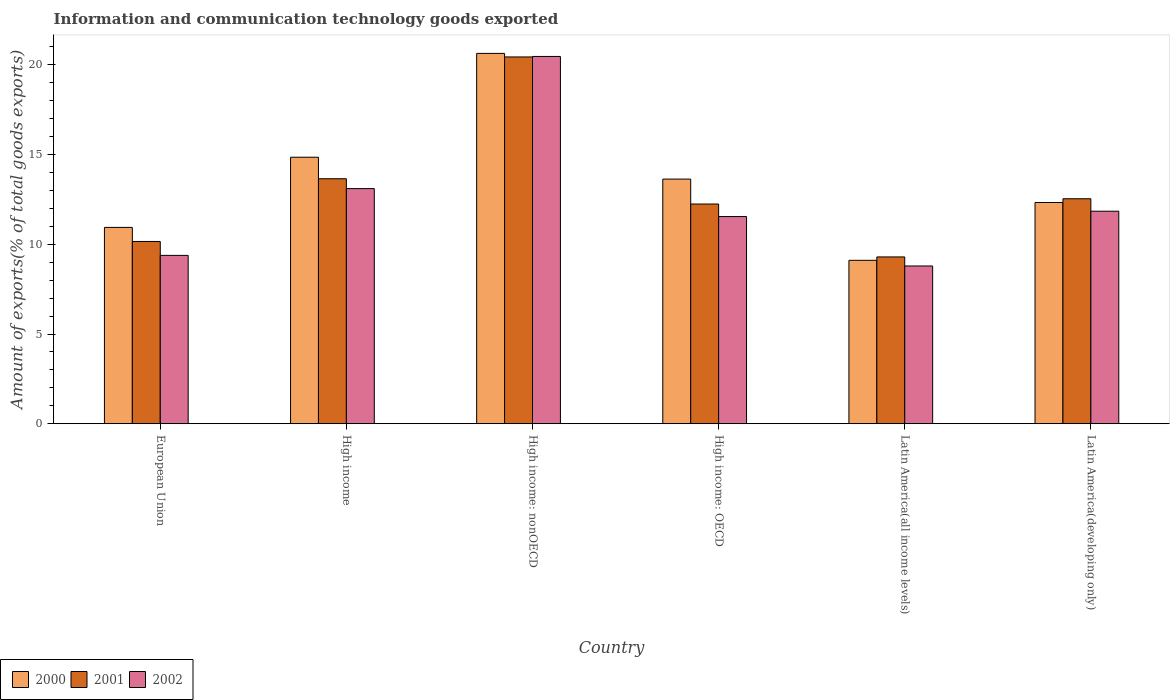How many different coloured bars are there?
Keep it short and to the point. 3. How many groups of bars are there?
Your answer should be very brief. 6. Are the number of bars per tick equal to the number of legend labels?
Your response must be concise. Yes. Are the number of bars on each tick of the X-axis equal?
Offer a terse response. Yes. How many bars are there on the 4th tick from the left?
Keep it short and to the point. 3. How many bars are there on the 5th tick from the right?
Offer a terse response. 3. What is the amount of goods exported in 2001 in High income: OECD?
Keep it short and to the point. 12.24. Across all countries, what is the maximum amount of goods exported in 2001?
Offer a terse response. 20.44. Across all countries, what is the minimum amount of goods exported in 2002?
Your answer should be very brief. 8.79. In which country was the amount of goods exported in 2002 maximum?
Provide a succinct answer. High income: nonOECD. In which country was the amount of goods exported in 2001 minimum?
Your answer should be very brief. Latin America(all income levels). What is the total amount of goods exported in 2001 in the graph?
Keep it short and to the point. 78.33. What is the difference between the amount of goods exported in 2001 in High income and that in Latin America(developing only)?
Your answer should be compact. 1.12. What is the difference between the amount of goods exported in 2002 in High income and the amount of goods exported in 2000 in High income: OECD?
Your answer should be compact. -0.53. What is the average amount of goods exported in 2001 per country?
Your answer should be very brief. 13.05. What is the difference between the amount of goods exported of/in 2001 and amount of goods exported of/in 2002 in Latin America(developing only)?
Provide a succinct answer. 0.69. What is the ratio of the amount of goods exported in 2002 in High income to that in Latin America(all income levels)?
Provide a succinct answer. 1.49. Is the amount of goods exported in 2001 in European Union less than that in High income?
Your response must be concise. Yes. Is the difference between the amount of goods exported in 2001 in High income and High income: OECD greater than the difference between the amount of goods exported in 2002 in High income and High income: OECD?
Offer a terse response. No. What is the difference between the highest and the second highest amount of goods exported in 2002?
Provide a short and direct response. -8.62. What is the difference between the highest and the lowest amount of goods exported in 2002?
Keep it short and to the point. 11.68. What does the 3rd bar from the left in High income: nonOECD represents?
Keep it short and to the point. 2002. What does the 2nd bar from the right in Latin America(all income levels) represents?
Keep it short and to the point. 2001. Are all the bars in the graph horizontal?
Keep it short and to the point. No. How many countries are there in the graph?
Make the answer very short. 6. Where does the legend appear in the graph?
Provide a short and direct response. Bottom left. How many legend labels are there?
Keep it short and to the point. 3. How are the legend labels stacked?
Offer a very short reply. Horizontal. What is the title of the graph?
Make the answer very short. Information and communication technology goods exported. Does "1992" appear as one of the legend labels in the graph?
Provide a succinct answer. No. What is the label or title of the X-axis?
Provide a short and direct response. Country. What is the label or title of the Y-axis?
Offer a very short reply. Amount of exports(% of total goods exports). What is the Amount of exports(% of total goods exports) in 2000 in European Union?
Ensure brevity in your answer.  10.94. What is the Amount of exports(% of total goods exports) of 2001 in European Union?
Give a very brief answer. 10.16. What is the Amount of exports(% of total goods exports) of 2002 in European Union?
Offer a very short reply. 9.38. What is the Amount of exports(% of total goods exports) of 2000 in High income?
Provide a succinct answer. 14.85. What is the Amount of exports(% of total goods exports) of 2001 in High income?
Give a very brief answer. 13.65. What is the Amount of exports(% of total goods exports) of 2002 in High income?
Keep it short and to the point. 13.1. What is the Amount of exports(% of total goods exports) in 2000 in High income: nonOECD?
Provide a short and direct response. 20.64. What is the Amount of exports(% of total goods exports) in 2001 in High income: nonOECD?
Your answer should be compact. 20.44. What is the Amount of exports(% of total goods exports) in 2002 in High income: nonOECD?
Make the answer very short. 20.47. What is the Amount of exports(% of total goods exports) in 2000 in High income: OECD?
Your response must be concise. 13.63. What is the Amount of exports(% of total goods exports) of 2001 in High income: OECD?
Make the answer very short. 12.24. What is the Amount of exports(% of total goods exports) of 2002 in High income: OECD?
Your response must be concise. 11.55. What is the Amount of exports(% of total goods exports) in 2000 in Latin America(all income levels)?
Your answer should be compact. 9.11. What is the Amount of exports(% of total goods exports) of 2001 in Latin America(all income levels)?
Provide a short and direct response. 9.3. What is the Amount of exports(% of total goods exports) in 2002 in Latin America(all income levels)?
Give a very brief answer. 8.79. What is the Amount of exports(% of total goods exports) in 2000 in Latin America(developing only)?
Your response must be concise. 12.33. What is the Amount of exports(% of total goods exports) in 2001 in Latin America(developing only)?
Your answer should be compact. 12.54. What is the Amount of exports(% of total goods exports) in 2002 in Latin America(developing only)?
Your response must be concise. 11.84. Across all countries, what is the maximum Amount of exports(% of total goods exports) of 2000?
Make the answer very short. 20.64. Across all countries, what is the maximum Amount of exports(% of total goods exports) in 2001?
Offer a very short reply. 20.44. Across all countries, what is the maximum Amount of exports(% of total goods exports) of 2002?
Your answer should be compact. 20.47. Across all countries, what is the minimum Amount of exports(% of total goods exports) in 2000?
Your answer should be very brief. 9.11. Across all countries, what is the minimum Amount of exports(% of total goods exports) of 2001?
Give a very brief answer. 9.3. Across all countries, what is the minimum Amount of exports(% of total goods exports) in 2002?
Offer a terse response. 8.79. What is the total Amount of exports(% of total goods exports) in 2000 in the graph?
Offer a terse response. 81.5. What is the total Amount of exports(% of total goods exports) in 2001 in the graph?
Your response must be concise. 78.33. What is the total Amount of exports(% of total goods exports) in 2002 in the graph?
Your response must be concise. 75.13. What is the difference between the Amount of exports(% of total goods exports) of 2000 in European Union and that in High income?
Your answer should be very brief. -3.91. What is the difference between the Amount of exports(% of total goods exports) of 2001 in European Union and that in High income?
Make the answer very short. -3.49. What is the difference between the Amount of exports(% of total goods exports) in 2002 in European Union and that in High income?
Provide a succinct answer. -3.72. What is the difference between the Amount of exports(% of total goods exports) in 2000 in European Union and that in High income: nonOECD?
Offer a very short reply. -9.7. What is the difference between the Amount of exports(% of total goods exports) in 2001 in European Union and that in High income: nonOECD?
Ensure brevity in your answer.  -10.28. What is the difference between the Amount of exports(% of total goods exports) in 2002 in European Union and that in High income: nonOECD?
Provide a short and direct response. -11.09. What is the difference between the Amount of exports(% of total goods exports) of 2000 in European Union and that in High income: OECD?
Offer a very short reply. -2.69. What is the difference between the Amount of exports(% of total goods exports) in 2001 in European Union and that in High income: OECD?
Offer a very short reply. -2.09. What is the difference between the Amount of exports(% of total goods exports) of 2002 in European Union and that in High income: OECD?
Offer a terse response. -2.16. What is the difference between the Amount of exports(% of total goods exports) of 2000 in European Union and that in Latin America(all income levels)?
Ensure brevity in your answer.  1.83. What is the difference between the Amount of exports(% of total goods exports) in 2001 in European Union and that in Latin America(all income levels)?
Offer a terse response. 0.86. What is the difference between the Amount of exports(% of total goods exports) in 2002 in European Union and that in Latin America(all income levels)?
Offer a terse response. 0.59. What is the difference between the Amount of exports(% of total goods exports) of 2000 in European Union and that in Latin America(developing only)?
Provide a succinct answer. -1.39. What is the difference between the Amount of exports(% of total goods exports) in 2001 in European Union and that in Latin America(developing only)?
Give a very brief answer. -2.38. What is the difference between the Amount of exports(% of total goods exports) of 2002 in European Union and that in Latin America(developing only)?
Provide a short and direct response. -2.46. What is the difference between the Amount of exports(% of total goods exports) in 2000 in High income and that in High income: nonOECD?
Offer a very short reply. -5.79. What is the difference between the Amount of exports(% of total goods exports) of 2001 in High income and that in High income: nonOECD?
Offer a very short reply. -6.79. What is the difference between the Amount of exports(% of total goods exports) of 2002 in High income and that in High income: nonOECD?
Offer a terse response. -7.36. What is the difference between the Amount of exports(% of total goods exports) in 2000 in High income and that in High income: OECD?
Your answer should be very brief. 1.22. What is the difference between the Amount of exports(% of total goods exports) in 2001 in High income and that in High income: OECD?
Your answer should be compact. 1.41. What is the difference between the Amount of exports(% of total goods exports) of 2002 in High income and that in High income: OECD?
Make the answer very short. 1.56. What is the difference between the Amount of exports(% of total goods exports) in 2000 in High income and that in Latin America(all income levels)?
Provide a succinct answer. 5.75. What is the difference between the Amount of exports(% of total goods exports) of 2001 in High income and that in Latin America(all income levels)?
Keep it short and to the point. 4.36. What is the difference between the Amount of exports(% of total goods exports) in 2002 in High income and that in Latin America(all income levels)?
Your response must be concise. 4.31. What is the difference between the Amount of exports(% of total goods exports) in 2000 in High income and that in Latin America(developing only)?
Keep it short and to the point. 2.52. What is the difference between the Amount of exports(% of total goods exports) in 2001 in High income and that in Latin America(developing only)?
Keep it short and to the point. 1.12. What is the difference between the Amount of exports(% of total goods exports) in 2002 in High income and that in Latin America(developing only)?
Offer a very short reply. 1.26. What is the difference between the Amount of exports(% of total goods exports) in 2000 in High income: nonOECD and that in High income: OECD?
Your answer should be very brief. 7. What is the difference between the Amount of exports(% of total goods exports) in 2001 in High income: nonOECD and that in High income: OECD?
Make the answer very short. 8.2. What is the difference between the Amount of exports(% of total goods exports) in 2002 in High income: nonOECD and that in High income: OECD?
Provide a succinct answer. 8.92. What is the difference between the Amount of exports(% of total goods exports) in 2000 in High income: nonOECD and that in Latin America(all income levels)?
Provide a short and direct response. 11.53. What is the difference between the Amount of exports(% of total goods exports) of 2001 in High income: nonOECD and that in Latin America(all income levels)?
Your response must be concise. 11.14. What is the difference between the Amount of exports(% of total goods exports) in 2002 in High income: nonOECD and that in Latin America(all income levels)?
Offer a very short reply. 11.68. What is the difference between the Amount of exports(% of total goods exports) in 2000 in High income: nonOECD and that in Latin America(developing only)?
Your response must be concise. 8.31. What is the difference between the Amount of exports(% of total goods exports) of 2001 in High income: nonOECD and that in Latin America(developing only)?
Make the answer very short. 7.9. What is the difference between the Amount of exports(% of total goods exports) of 2002 in High income: nonOECD and that in Latin America(developing only)?
Your answer should be compact. 8.62. What is the difference between the Amount of exports(% of total goods exports) of 2000 in High income: OECD and that in Latin America(all income levels)?
Give a very brief answer. 4.53. What is the difference between the Amount of exports(% of total goods exports) in 2001 in High income: OECD and that in Latin America(all income levels)?
Your response must be concise. 2.95. What is the difference between the Amount of exports(% of total goods exports) of 2002 in High income: OECD and that in Latin America(all income levels)?
Offer a very short reply. 2.75. What is the difference between the Amount of exports(% of total goods exports) of 2000 in High income: OECD and that in Latin America(developing only)?
Offer a terse response. 1.3. What is the difference between the Amount of exports(% of total goods exports) of 2001 in High income: OECD and that in Latin America(developing only)?
Offer a very short reply. -0.29. What is the difference between the Amount of exports(% of total goods exports) in 2002 in High income: OECD and that in Latin America(developing only)?
Provide a succinct answer. -0.3. What is the difference between the Amount of exports(% of total goods exports) in 2000 in Latin America(all income levels) and that in Latin America(developing only)?
Provide a short and direct response. -3.22. What is the difference between the Amount of exports(% of total goods exports) in 2001 in Latin America(all income levels) and that in Latin America(developing only)?
Offer a terse response. -3.24. What is the difference between the Amount of exports(% of total goods exports) of 2002 in Latin America(all income levels) and that in Latin America(developing only)?
Offer a terse response. -3.05. What is the difference between the Amount of exports(% of total goods exports) in 2000 in European Union and the Amount of exports(% of total goods exports) in 2001 in High income?
Your response must be concise. -2.71. What is the difference between the Amount of exports(% of total goods exports) of 2000 in European Union and the Amount of exports(% of total goods exports) of 2002 in High income?
Provide a succinct answer. -2.16. What is the difference between the Amount of exports(% of total goods exports) of 2001 in European Union and the Amount of exports(% of total goods exports) of 2002 in High income?
Ensure brevity in your answer.  -2.95. What is the difference between the Amount of exports(% of total goods exports) in 2000 in European Union and the Amount of exports(% of total goods exports) in 2001 in High income: nonOECD?
Your answer should be very brief. -9.5. What is the difference between the Amount of exports(% of total goods exports) in 2000 in European Union and the Amount of exports(% of total goods exports) in 2002 in High income: nonOECD?
Offer a terse response. -9.53. What is the difference between the Amount of exports(% of total goods exports) of 2001 in European Union and the Amount of exports(% of total goods exports) of 2002 in High income: nonOECD?
Provide a short and direct response. -10.31. What is the difference between the Amount of exports(% of total goods exports) in 2000 in European Union and the Amount of exports(% of total goods exports) in 2001 in High income: OECD?
Keep it short and to the point. -1.3. What is the difference between the Amount of exports(% of total goods exports) in 2000 in European Union and the Amount of exports(% of total goods exports) in 2002 in High income: OECD?
Your answer should be very brief. -0.6. What is the difference between the Amount of exports(% of total goods exports) of 2001 in European Union and the Amount of exports(% of total goods exports) of 2002 in High income: OECD?
Your answer should be very brief. -1.39. What is the difference between the Amount of exports(% of total goods exports) in 2000 in European Union and the Amount of exports(% of total goods exports) in 2001 in Latin America(all income levels)?
Offer a terse response. 1.64. What is the difference between the Amount of exports(% of total goods exports) of 2000 in European Union and the Amount of exports(% of total goods exports) of 2002 in Latin America(all income levels)?
Make the answer very short. 2.15. What is the difference between the Amount of exports(% of total goods exports) of 2001 in European Union and the Amount of exports(% of total goods exports) of 2002 in Latin America(all income levels)?
Your response must be concise. 1.37. What is the difference between the Amount of exports(% of total goods exports) in 2000 in European Union and the Amount of exports(% of total goods exports) in 2001 in Latin America(developing only)?
Your answer should be very brief. -1.6. What is the difference between the Amount of exports(% of total goods exports) in 2000 in European Union and the Amount of exports(% of total goods exports) in 2002 in Latin America(developing only)?
Make the answer very short. -0.9. What is the difference between the Amount of exports(% of total goods exports) in 2001 in European Union and the Amount of exports(% of total goods exports) in 2002 in Latin America(developing only)?
Offer a very short reply. -1.69. What is the difference between the Amount of exports(% of total goods exports) in 2000 in High income and the Amount of exports(% of total goods exports) in 2001 in High income: nonOECD?
Keep it short and to the point. -5.59. What is the difference between the Amount of exports(% of total goods exports) of 2000 in High income and the Amount of exports(% of total goods exports) of 2002 in High income: nonOECD?
Ensure brevity in your answer.  -5.62. What is the difference between the Amount of exports(% of total goods exports) in 2001 in High income and the Amount of exports(% of total goods exports) in 2002 in High income: nonOECD?
Provide a short and direct response. -6.81. What is the difference between the Amount of exports(% of total goods exports) in 2000 in High income and the Amount of exports(% of total goods exports) in 2001 in High income: OECD?
Provide a succinct answer. 2.61. What is the difference between the Amount of exports(% of total goods exports) of 2000 in High income and the Amount of exports(% of total goods exports) of 2002 in High income: OECD?
Your answer should be very brief. 3.31. What is the difference between the Amount of exports(% of total goods exports) in 2001 in High income and the Amount of exports(% of total goods exports) in 2002 in High income: OECD?
Your answer should be compact. 2.11. What is the difference between the Amount of exports(% of total goods exports) of 2000 in High income and the Amount of exports(% of total goods exports) of 2001 in Latin America(all income levels)?
Give a very brief answer. 5.56. What is the difference between the Amount of exports(% of total goods exports) of 2000 in High income and the Amount of exports(% of total goods exports) of 2002 in Latin America(all income levels)?
Give a very brief answer. 6.06. What is the difference between the Amount of exports(% of total goods exports) in 2001 in High income and the Amount of exports(% of total goods exports) in 2002 in Latin America(all income levels)?
Keep it short and to the point. 4.86. What is the difference between the Amount of exports(% of total goods exports) in 2000 in High income and the Amount of exports(% of total goods exports) in 2001 in Latin America(developing only)?
Provide a succinct answer. 2.31. What is the difference between the Amount of exports(% of total goods exports) of 2000 in High income and the Amount of exports(% of total goods exports) of 2002 in Latin America(developing only)?
Give a very brief answer. 3.01. What is the difference between the Amount of exports(% of total goods exports) in 2001 in High income and the Amount of exports(% of total goods exports) in 2002 in Latin America(developing only)?
Ensure brevity in your answer.  1.81. What is the difference between the Amount of exports(% of total goods exports) in 2000 in High income: nonOECD and the Amount of exports(% of total goods exports) in 2001 in High income: OECD?
Ensure brevity in your answer.  8.39. What is the difference between the Amount of exports(% of total goods exports) in 2000 in High income: nonOECD and the Amount of exports(% of total goods exports) in 2002 in High income: OECD?
Your response must be concise. 9.09. What is the difference between the Amount of exports(% of total goods exports) in 2001 in High income: nonOECD and the Amount of exports(% of total goods exports) in 2002 in High income: OECD?
Make the answer very short. 8.89. What is the difference between the Amount of exports(% of total goods exports) of 2000 in High income: nonOECD and the Amount of exports(% of total goods exports) of 2001 in Latin America(all income levels)?
Provide a succinct answer. 11.34. What is the difference between the Amount of exports(% of total goods exports) in 2000 in High income: nonOECD and the Amount of exports(% of total goods exports) in 2002 in Latin America(all income levels)?
Your answer should be compact. 11.85. What is the difference between the Amount of exports(% of total goods exports) of 2001 in High income: nonOECD and the Amount of exports(% of total goods exports) of 2002 in Latin America(all income levels)?
Your response must be concise. 11.65. What is the difference between the Amount of exports(% of total goods exports) of 2000 in High income: nonOECD and the Amount of exports(% of total goods exports) of 2001 in Latin America(developing only)?
Keep it short and to the point. 8.1. What is the difference between the Amount of exports(% of total goods exports) of 2000 in High income: nonOECD and the Amount of exports(% of total goods exports) of 2002 in Latin America(developing only)?
Give a very brief answer. 8.79. What is the difference between the Amount of exports(% of total goods exports) in 2001 in High income: nonOECD and the Amount of exports(% of total goods exports) in 2002 in Latin America(developing only)?
Provide a succinct answer. 8.6. What is the difference between the Amount of exports(% of total goods exports) of 2000 in High income: OECD and the Amount of exports(% of total goods exports) of 2001 in Latin America(all income levels)?
Your answer should be very brief. 4.34. What is the difference between the Amount of exports(% of total goods exports) of 2000 in High income: OECD and the Amount of exports(% of total goods exports) of 2002 in Latin America(all income levels)?
Offer a very short reply. 4.84. What is the difference between the Amount of exports(% of total goods exports) of 2001 in High income: OECD and the Amount of exports(% of total goods exports) of 2002 in Latin America(all income levels)?
Provide a short and direct response. 3.45. What is the difference between the Amount of exports(% of total goods exports) of 2000 in High income: OECD and the Amount of exports(% of total goods exports) of 2001 in Latin America(developing only)?
Offer a very short reply. 1.1. What is the difference between the Amount of exports(% of total goods exports) of 2000 in High income: OECD and the Amount of exports(% of total goods exports) of 2002 in Latin America(developing only)?
Make the answer very short. 1.79. What is the difference between the Amount of exports(% of total goods exports) in 2001 in High income: OECD and the Amount of exports(% of total goods exports) in 2002 in Latin America(developing only)?
Your response must be concise. 0.4. What is the difference between the Amount of exports(% of total goods exports) in 2000 in Latin America(all income levels) and the Amount of exports(% of total goods exports) in 2001 in Latin America(developing only)?
Offer a very short reply. -3.43. What is the difference between the Amount of exports(% of total goods exports) of 2000 in Latin America(all income levels) and the Amount of exports(% of total goods exports) of 2002 in Latin America(developing only)?
Offer a very short reply. -2.74. What is the difference between the Amount of exports(% of total goods exports) of 2001 in Latin America(all income levels) and the Amount of exports(% of total goods exports) of 2002 in Latin America(developing only)?
Your answer should be compact. -2.55. What is the average Amount of exports(% of total goods exports) in 2000 per country?
Ensure brevity in your answer.  13.58. What is the average Amount of exports(% of total goods exports) of 2001 per country?
Give a very brief answer. 13.05. What is the average Amount of exports(% of total goods exports) in 2002 per country?
Offer a very short reply. 12.52. What is the difference between the Amount of exports(% of total goods exports) in 2000 and Amount of exports(% of total goods exports) in 2001 in European Union?
Provide a short and direct response. 0.78. What is the difference between the Amount of exports(% of total goods exports) in 2000 and Amount of exports(% of total goods exports) in 2002 in European Union?
Offer a very short reply. 1.56. What is the difference between the Amount of exports(% of total goods exports) of 2001 and Amount of exports(% of total goods exports) of 2002 in European Union?
Ensure brevity in your answer.  0.78. What is the difference between the Amount of exports(% of total goods exports) of 2000 and Amount of exports(% of total goods exports) of 2001 in High income?
Offer a very short reply. 1.2. What is the difference between the Amount of exports(% of total goods exports) of 2000 and Amount of exports(% of total goods exports) of 2002 in High income?
Offer a very short reply. 1.75. What is the difference between the Amount of exports(% of total goods exports) in 2001 and Amount of exports(% of total goods exports) in 2002 in High income?
Give a very brief answer. 0.55. What is the difference between the Amount of exports(% of total goods exports) in 2000 and Amount of exports(% of total goods exports) in 2001 in High income: nonOECD?
Provide a short and direct response. 0.2. What is the difference between the Amount of exports(% of total goods exports) of 2000 and Amount of exports(% of total goods exports) of 2002 in High income: nonOECD?
Offer a terse response. 0.17. What is the difference between the Amount of exports(% of total goods exports) of 2001 and Amount of exports(% of total goods exports) of 2002 in High income: nonOECD?
Offer a terse response. -0.03. What is the difference between the Amount of exports(% of total goods exports) in 2000 and Amount of exports(% of total goods exports) in 2001 in High income: OECD?
Ensure brevity in your answer.  1.39. What is the difference between the Amount of exports(% of total goods exports) of 2000 and Amount of exports(% of total goods exports) of 2002 in High income: OECD?
Offer a very short reply. 2.09. What is the difference between the Amount of exports(% of total goods exports) in 2001 and Amount of exports(% of total goods exports) in 2002 in High income: OECD?
Ensure brevity in your answer.  0.7. What is the difference between the Amount of exports(% of total goods exports) of 2000 and Amount of exports(% of total goods exports) of 2001 in Latin America(all income levels)?
Offer a terse response. -0.19. What is the difference between the Amount of exports(% of total goods exports) of 2000 and Amount of exports(% of total goods exports) of 2002 in Latin America(all income levels)?
Ensure brevity in your answer.  0.32. What is the difference between the Amount of exports(% of total goods exports) of 2001 and Amount of exports(% of total goods exports) of 2002 in Latin America(all income levels)?
Keep it short and to the point. 0.5. What is the difference between the Amount of exports(% of total goods exports) of 2000 and Amount of exports(% of total goods exports) of 2001 in Latin America(developing only)?
Ensure brevity in your answer.  -0.21. What is the difference between the Amount of exports(% of total goods exports) of 2000 and Amount of exports(% of total goods exports) of 2002 in Latin America(developing only)?
Your answer should be very brief. 0.49. What is the difference between the Amount of exports(% of total goods exports) in 2001 and Amount of exports(% of total goods exports) in 2002 in Latin America(developing only)?
Give a very brief answer. 0.69. What is the ratio of the Amount of exports(% of total goods exports) of 2000 in European Union to that in High income?
Provide a short and direct response. 0.74. What is the ratio of the Amount of exports(% of total goods exports) of 2001 in European Union to that in High income?
Your response must be concise. 0.74. What is the ratio of the Amount of exports(% of total goods exports) of 2002 in European Union to that in High income?
Offer a very short reply. 0.72. What is the ratio of the Amount of exports(% of total goods exports) in 2000 in European Union to that in High income: nonOECD?
Your answer should be compact. 0.53. What is the ratio of the Amount of exports(% of total goods exports) in 2001 in European Union to that in High income: nonOECD?
Keep it short and to the point. 0.5. What is the ratio of the Amount of exports(% of total goods exports) of 2002 in European Union to that in High income: nonOECD?
Your response must be concise. 0.46. What is the ratio of the Amount of exports(% of total goods exports) in 2000 in European Union to that in High income: OECD?
Give a very brief answer. 0.8. What is the ratio of the Amount of exports(% of total goods exports) of 2001 in European Union to that in High income: OECD?
Your response must be concise. 0.83. What is the ratio of the Amount of exports(% of total goods exports) of 2002 in European Union to that in High income: OECD?
Give a very brief answer. 0.81. What is the ratio of the Amount of exports(% of total goods exports) in 2000 in European Union to that in Latin America(all income levels)?
Your answer should be compact. 1.2. What is the ratio of the Amount of exports(% of total goods exports) of 2001 in European Union to that in Latin America(all income levels)?
Your answer should be very brief. 1.09. What is the ratio of the Amount of exports(% of total goods exports) in 2002 in European Union to that in Latin America(all income levels)?
Give a very brief answer. 1.07. What is the ratio of the Amount of exports(% of total goods exports) of 2000 in European Union to that in Latin America(developing only)?
Your response must be concise. 0.89. What is the ratio of the Amount of exports(% of total goods exports) in 2001 in European Union to that in Latin America(developing only)?
Offer a very short reply. 0.81. What is the ratio of the Amount of exports(% of total goods exports) of 2002 in European Union to that in Latin America(developing only)?
Give a very brief answer. 0.79. What is the ratio of the Amount of exports(% of total goods exports) of 2000 in High income to that in High income: nonOECD?
Provide a short and direct response. 0.72. What is the ratio of the Amount of exports(% of total goods exports) of 2001 in High income to that in High income: nonOECD?
Keep it short and to the point. 0.67. What is the ratio of the Amount of exports(% of total goods exports) in 2002 in High income to that in High income: nonOECD?
Your response must be concise. 0.64. What is the ratio of the Amount of exports(% of total goods exports) in 2000 in High income to that in High income: OECD?
Give a very brief answer. 1.09. What is the ratio of the Amount of exports(% of total goods exports) of 2001 in High income to that in High income: OECD?
Provide a short and direct response. 1.12. What is the ratio of the Amount of exports(% of total goods exports) in 2002 in High income to that in High income: OECD?
Keep it short and to the point. 1.13. What is the ratio of the Amount of exports(% of total goods exports) in 2000 in High income to that in Latin America(all income levels)?
Provide a succinct answer. 1.63. What is the ratio of the Amount of exports(% of total goods exports) of 2001 in High income to that in Latin America(all income levels)?
Make the answer very short. 1.47. What is the ratio of the Amount of exports(% of total goods exports) of 2002 in High income to that in Latin America(all income levels)?
Offer a terse response. 1.49. What is the ratio of the Amount of exports(% of total goods exports) of 2000 in High income to that in Latin America(developing only)?
Give a very brief answer. 1.2. What is the ratio of the Amount of exports(% of total goods exports) of 2001 in High income to that in Latin America(developing only)?
Provide a succinct answer. 1.09. What is the ratio of the Amount of exports(% of total goods exports) in 2002 in High income to that in Latin America(developing only)?
Ensure brevity in your answer.  1.11. What is the ratio of the Amount of exports(% of total goods exports) of 2000 in High income: nonOECD to that in High income: OECD?
Your answer should be compact. 1.51. What is the ratio of the Amount of exports(% of total goods exports) in 2001 in High income: nonOECD to that in High income: OECD?
Make the answer very short. 1.67. What is the ratio of the Amount of exports(% of total goods exports) of 2002 in High income: nonOECD to that in High income: OECD?
Provide a succinct answer. 1.77. What is the ratio of the Amount of exports(% of total goods exports) in 2000 in High income: nonOECD to that in Latin America(all income levels)?
Your answer should be compact. 2.27. What is the ratio of the Amount of exports(% of total goods exports) of 2001 in High income: nonOECD to that in Latin America(all income levels)?
Offer a terse response. 2.2. What is the ratio of the Amount of exports(% of total goods exports) of 2002 in High income: nonOECD to that in Latin America(all income levels)?
Provide a succinct answer. 2.33. What is the ratio of the Amount of exports(% of total goods exports) of 2000 in High income: nonOECD to that in Latin America(developing only)?
Your response must be concise. 1.67. What is the ratio of the Amount of exports(% of total goods exports) of 2001 in High income: nonOECD to that in Latin America(developing only)?
Offer a terse response. 1.63. What is the ratio of the Amount of exports(% of total goods exports) in 2002 in High income: nonOECD to that in Latin America(developing only)?
Offer a terse response. 1.73. What is the ratio of the Amount of exports(% of total goods exports) in 2000 in High income: OECD to that in Latin America(all income levels)?
Offer a very short reply. 1.5. What is the ratio of the Amount of exports(% of total goods exports) of 2001 in High income: OECD to that in Latin America(all income levels)?
Give a very brief answer. 1.32. What is the ratio of the Amount of exports(% of total goods exports) in 2002 in High income: OECD to that in Latin America(all income levels)?
Provide a succinct answer. 1.31. What is the ratio of the Amount of exports(% of total goods exports) in 2000 in High income: OECD to that in Latin America(developing only)?
Offer a terse response. 1.11. What is the ratio of the Amount of exports(% of total goods exports) in 2001 in High income: OECD to that in Latin America(developing only)?
Provide a succinct answer. 0.98. What is the ratio of the Amount of exports(% of total goods exports) of 2002 in High income: OECD to that in Latin America(developing only)?
Keep it short and to the point. 0.97. What is the ratio of the Amount of exports(% of total goods exports) in 2000 in Latin America(all income levels) to that in Latin America(developing only)?
Offer a very short reply. 0.74. What is the ratio of the Amount of exports(% of total goods exports) of 2001 in Latin America(all income levels) to that in Latin America(developing only)?
Make the answer very short. 0.74. What is the ratio of the Amount of exports(% of total goods exports) of 2002 in Latin America(all income levels) to that in Latin America(developing only)?
Offer a very short reply. 0.74. What is the difference between the highest and the second highest Amount of exports(% of total goods exports) in 2000?
Ensure brevity in your answer.  5.79. What is the difference between the highest and the second highest Amount of exports(% of total goods exports) in 2001?
Give a very brief answer. 6.79. What is the difference between the highest and the second highest Amount of exports(% of total goods exports) of 2002?
Offer a very short reply. 7.36. What is the difference between the highest and the lowest Amount of exports(% of total goods exports) in 2000?
Offer a terse response. 11.53. What is the difference between the highest and the lowest Amount of exports(% of total goods exports) in 2001?
Your response must be concise. 11.14. What is the difference between the highest and the lowest Amount of exports(% of total goods exports) of 2002?
Your answer should be compact. 11.68. 